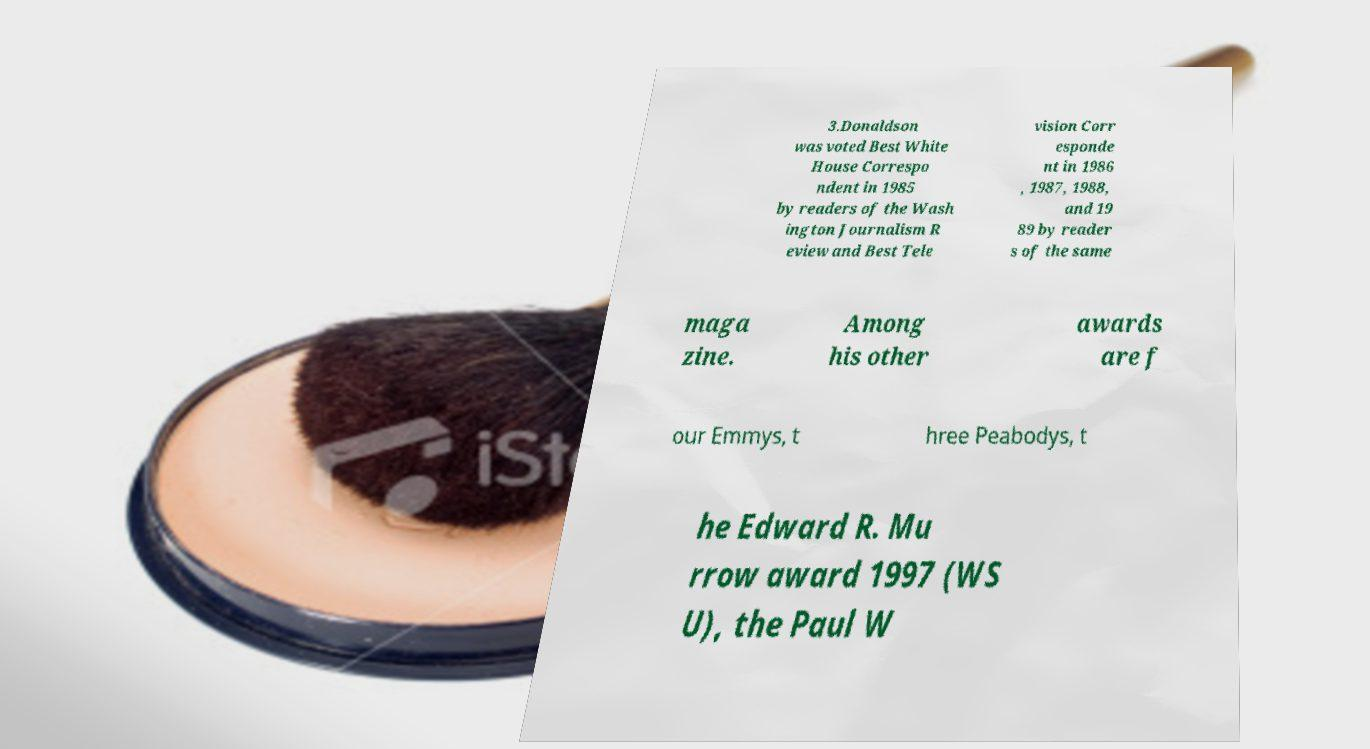There's text embedded in this image that I need extracted. Can you transcribe it verbatim? 3.Donaldson was voted Best White House Correspo ndent in 1985 by readers of the Wash ington Journalism R eview and Best Tele vision Corr esponde nt in 1986 , 1987, 1988, and 19 89 by reader s of the same maga zine. Among his other awards are f our Emmys, t hree Peabodys, t he Edward R. Mu rrow award 1997 (WS U), the Paul W 